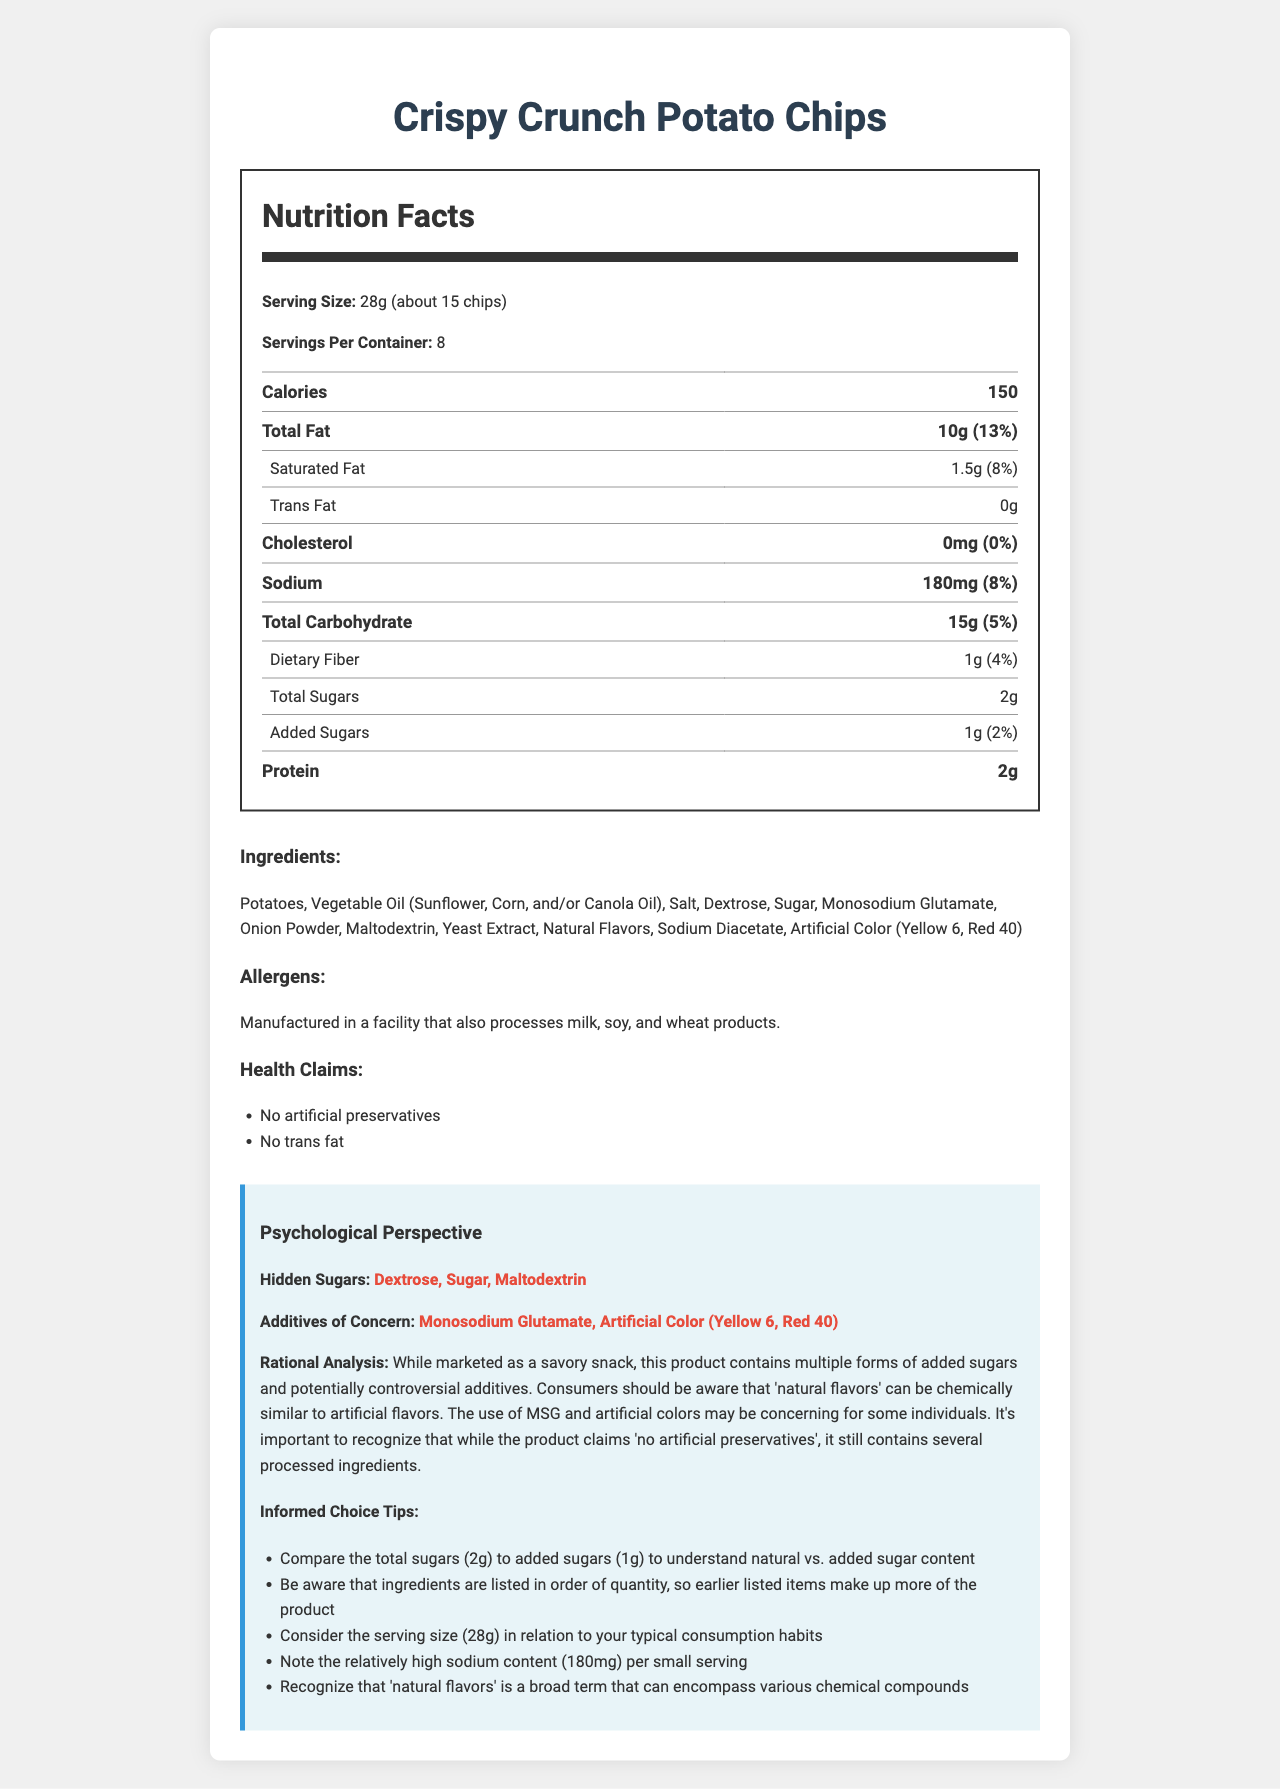what is the serving size of Crispy Crunch Potato Chips? The serving size is explicitly stated at the beginning of the Nutrition Facts section.
Answer: 28g (about 15 chips) how many calories are there per serving? The number of calories per serving is clearly mentioned under the Calories section of the Nutrition Facts.
Answer: 150 which additives are of concern according to the psychological perspective? These additives are highlighted under the "Additives of Concern" section in the Psychological Perspective area.
Answer: Monosodium Glutamate, Artificial Color (Yellow 6, Red 40) how much total sugar is in each serving? The total sugar content is listed in the Nutrition Facts table under the Total Sugars row.
Answer: 2g what health claims are made about these potato chips? The health claims are listed under the Health Claims section of the document.
Answer: No artificial preservatives, No trans fat how much sodium is in one serving of Crispy Crunch Potato Chips? The sodium content per serving is listed in the Nutrition Facts under the Sodium section.
Answer: 180mg which ingredient is listed first in the ingredients list? Ingredients are listed in descending order by quantity, and Potatoes is the first ingredient listed.
Answer: Potatoes how many servings are there in one container? The document states that there are 8 servings per container under the Servings Per Container section.
Answer: 8 do the Crispy Crunch Potato Chips contain any added sugars? The label specifies that there is 1g of Added Sugars per serving.
Answer: Yes what is the main idea of the document? The document combines Nutrition Facts, ingredients, health claims, and psychological analysis to guide consumers.
Answer: The document provides detailed nutritional information, ingredient lists, and psychological perspectives on Crispy Crunch Potato Chips, emphasizing hidden sugars and additives to help consumers make informed choices. how much protein is in a serving of Crispy Crunch Potato Chips? A. 1g B. 2g C. 3g The protein content per serving is listed as 2g under the Protein section in the Nutrition Facts.
Answer: B. 2g how much dietary fiber does one serving contain? A. 0.5g B. 1g C. 1.5g D. 2g The dietary fiber content per serving is listed as 1g under the Dietary Fiber section in the Nutrition Facts.
Answer: B. 1g are there any artificial colors included in the ingredients? The document lists artificial colors under the ingredients, particularly Yellow 6 and Red 40.
Answer: Yes is the amount of total carbohydrates more than the amount of total fat in one serving? The total carbohydrates are 15g and the total fat is 10g per serving, so the total fat is less than the total carbohydrates.
Answer: No which form of sugar is not present in the ingredients list? The document lists the specific sugars used, but it doesn’t provide a full list of all possible forms of sugar that are not included, making it uncertain which specific form of sugar might be absent.
Answer: Not enough information 